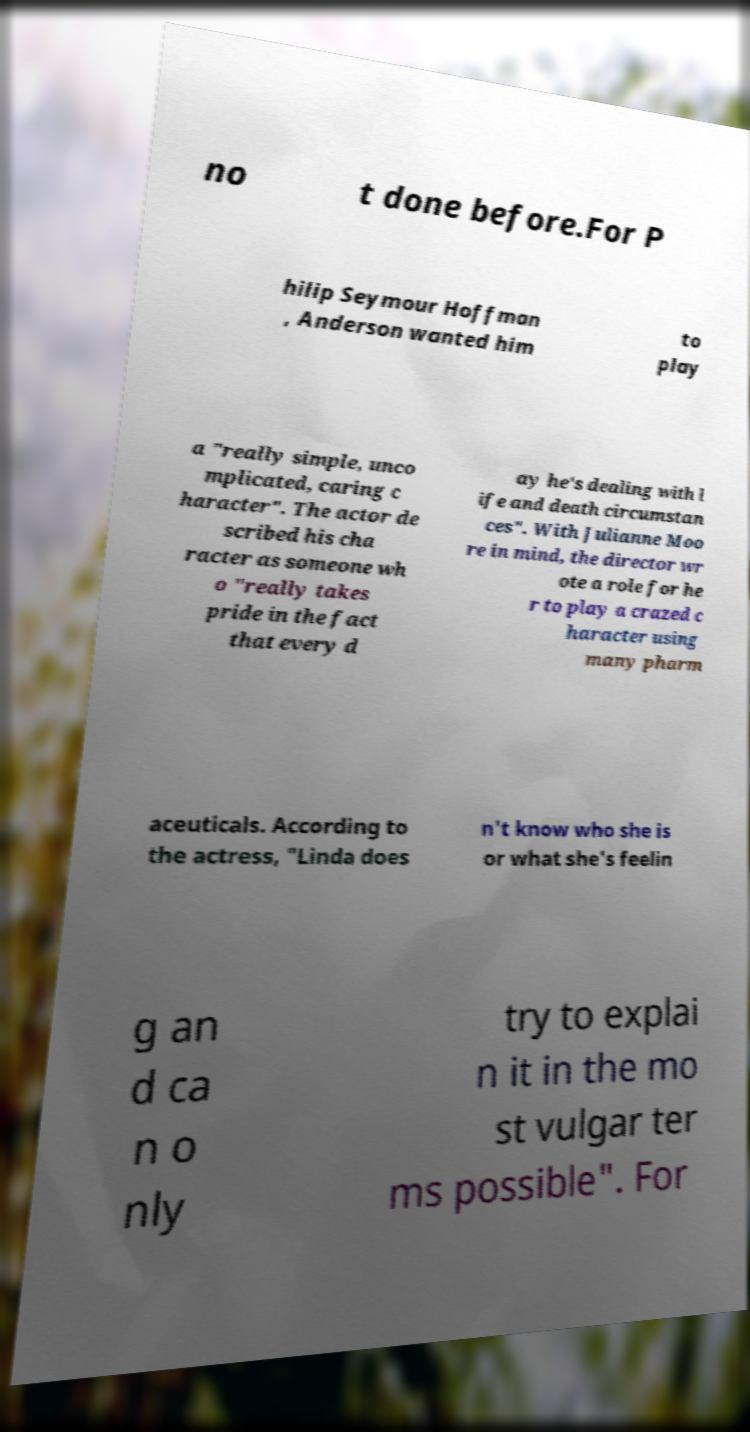Please read and relay the text visible in this image. What does it say? no t done before.For P hilip Seymour Hoffman , Anderson wanted him to play a "really simple, unco mplicated, caring c haracter". The actor de scribed his cha racter as someone wh o "really takes pride in the fact that every d ay he's dealing with l ife and death circumstan ces". With Julianne Moo re in mind, the director wr ote a role for he r to play a crazed c haracter using many pharm aceuticals. According to the actress, "Linda does n't know who she is or what she's feelin g an d ca n o nly try to explai n it in the mo st vulgar ter ms possible". For 